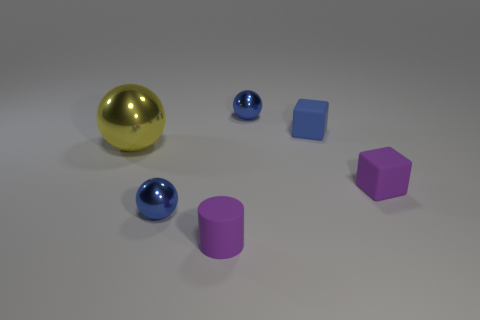Subtract all blue balls. How many balls are left? 1 Subtract all brown cylinders. How many blue spheres are left? 2 Subtract all yellow balls. How many balls are left? 2 Add 1 yellow balls. How many objects exist? 7 Subtract all cylinders. How many objects are left? 5 Subtract 2 cubes. How many cubes are left? 0 Subtract all gray cylinders. Subtract all gray spheres. How many cylinders are left? 1 Subtract all big yellow spheres. Subtract all tiny purple matte cylinders. How many objects are left? 4 Add 3 large yellow balls. How many large yellow balls are left? 4 Add 4 large yellow objects. How many large yellow objects exist? 5 